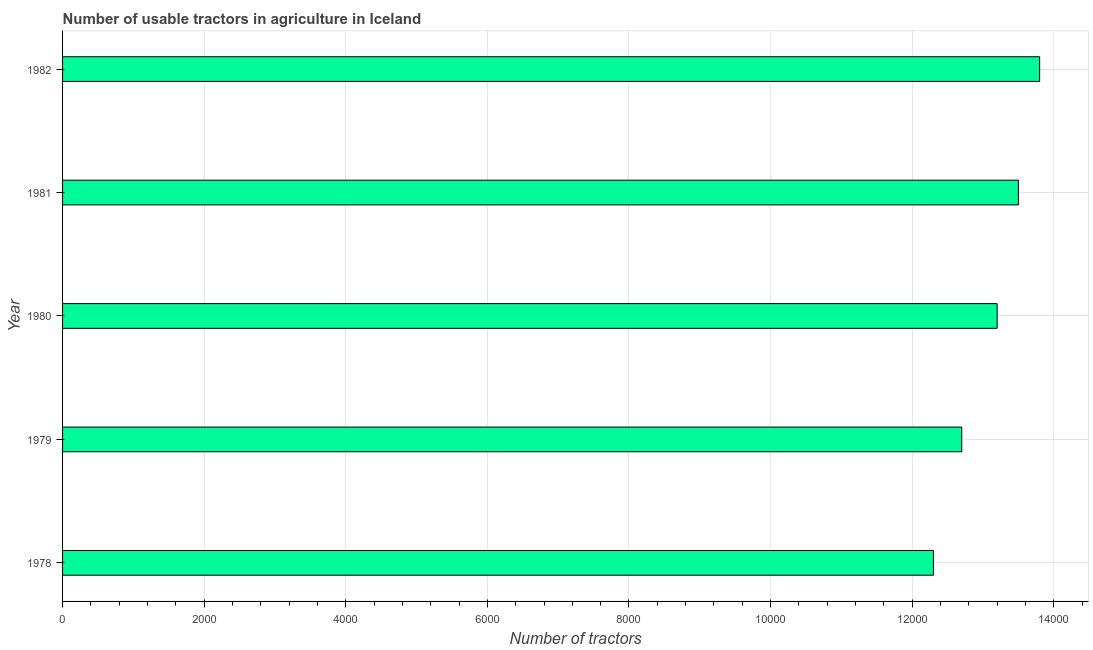What is the title of the graph?
Your response must be concise. Number of usable tractors in agriculture in Iceland. What is the label or title of the X-axis?
Ensure brevity in your answer.  Number of tractors. What is the number of tractors in 1981?
Your answer should be compact. 1.35e+04. Across all years, what is the maximum number of tractors?
Give a very brief answer. 1.38e+04. Across all years, what is the minimum number of tractors?
Offer a terse response. 1.23e+04. In which year was the number of tractors maximum?
Offer a very short reply. 1982. In which year was the number of tractors minimum?
Your answer should be very brief. 1978. What is the sum of the number of tractors?
Keep it short and to the point. 6.55e+04. What is the difference between the number of tractors in 1979 and 1980?
Provide a succinct answer. -500. What is the average number of tractors per year?
Your answer should be compact. 1.31e+04. What is the median number of tractors?
Give a very brief answer. 1.32e+04. In how many years, is the number of tractors greater than 3200 ?
Your response must be concise. 5. Do a majority of the years between 1982 and 1978 (inclusive) have number of tractors greater than 4000 ?
Ensure brevity in your answer.  Yes. Is the number of tractors in 1981 less than that in 1982?
Your response must be concise. Yes. Is the difference between the number of tractors in 1980 and 1982 greater than the difference between any two years?
Provide a succinct answer. No. What is the difference between the highest and the second highest number of tractors?
Give a very brief answer. 300. Is the sum of the number of tractors in 1980 and 1981 greater than the maximum number of tractors across all years?
Your answer should be very brief. Yes. What is the difference between the highest and the lowest number of tractors?
Provide a succinct answer. 1500. What is the Number of tractors in 1978?
Provide a succinct answer. 1.23e+04. What is the Number of tractors in 1979?
Make the answer very short. 1.27e+04. What is the Number of tractors in 1980?
Make the answer very short. 1.32e+04. What is the Number of tractors in 1981?
Provide a short and direct response. 1.35e+04. What is the Number of tractors in 1982?
Your response must be concise. 1.38e+04. What is the difference between the Number of tractors in 1978 and 1979?
Provide a short and direct response. -400. What is the difference between the Number of tractors in 1978 and 1980?
Offer a terse response. -900. What is the difference between the Number of tractors in 1978 and 1981?
Offer a very short reply. -1200. What is the difference between the Number of tractors in 1978 and 1982?
Ensure brevity in your answer.  -1500. What is the difference between the Number of tractors in 1979 and 1980?
Keep it short and to the point. -500. What is the difference between the Number of tractors in 1979 and 1981?
Your response must be concise. -800. What is the difference between the Number of tractors in 1979 and 1982?
Give a very brief answer. -1100. What is the difference between the Number of tractors in 1980 and 1981?
Give a very brief answer. -300. What is the difference between the Number of tractors in 1980 and 1982?
Give a very brief answer. -600. What is the difference between the Number of tractors in 1981 and 1982?
Provide a short and direct response. -300. What is the ratio of the Number of tractors in 1978 to that in 1979?
Keep it short and to the point. 0.97. What is the ratio of the Number of tractors in 1978 to that in 1980?
Ensure brevity in your answer.  0.93. What is the ratio of the Number of tractors in 1978 to that in 1981?
Your answer should be compact. 0.91. What is the ratio of the Number of tractors in 1978 to that in 1982?
Offer a terse response. 0.89. What is the ratio of the Number of tractors in 1979 to that in 1981?
Provide a succinct answer. 0.94. What is the ratio of the Number of tractors in 1979 to that in 1982?
Offer a very short reply. 0.92. 